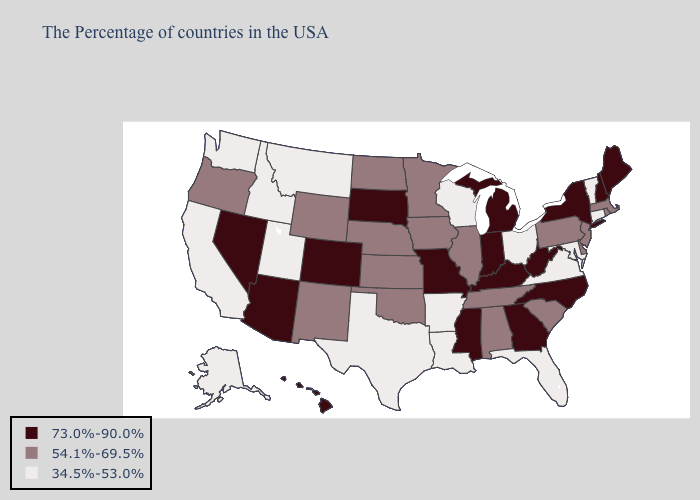Is the legend a continuous bar?
Write a very short answer. No. Name the states that have a value in the range 54.1%-69.5%?
Short answer required. Massachusetts, Rhode Island, New Jersey, Delaware, Pennsylvania, South Carolina, Alabama, Tennessee, Illinois, Minnesota, Iowa, Kansas, Nebraska, Oklahoma, North Dakota, Wyoming, New Mexico, Oregon. What is the value of Arkansas?
Answer briefly. 34.5%-53.0%. What is the lowest value in the West?
Be succinct. 34.5%-53.0%. Name the states that have a value in the range 73.0%-90.0%?
Be succinct. Maine, New Hampshire, New York, North Carolina, West Virginia, Georgia, Michigan, Kentucky, Indiana, Mississippi, Missouri, South Dakota, Colorado, Arizona, Nevada, Hawaii. Does South Dakota have the highest value in the USA?
Write a very short answer. Yes. Name the states that have a value in the range 73.0%-90.0%?
Write a very short answer. Maine, New Hampshire, New York, North Carolina, West Virginia, Georgia, Michigan, Kentucky, Indiana, Mississippi, Missouri, South Dakota, Colorado, Arizona, Nevada, Hawaii. Which states hav the highest value in the Northeast?
Quick response, please. Maine, New Hampshire, New York. Name the states that have a value in the range 73.0%-90.0%?
Write a very short answer. Maine, New Hampshire, New York, North Carolina, West Virginia, Georgia, Michigan, Kentucky, Indiana, Mississippi, Missouri, South Dakota, Colorado, Arizona, Nevada, Hawaii. Name the states that have a value in the range 73.0%-90.0%?
Quick response, please. Maine, New Hampshire, New York, North Carolina, West Virginia, Georgia, Michigan, Kentucky, Indiana, Mississippi, Missouri, South Dakota, Colorado, Arizona, Nevada, Hawaii. What is the highest value in states that border West Virginia?
Concise answer only. 73.0%-90.0%. What is the value of Iowa?
Quick response, please. 54.1%-69.5%. Does Idaho have the lowest value in the West?
Give a very brief answer. Yes. What is the value of Rhode Island?
Give a very brief answer. 54.1%-69.5%. What is the value of Kansas?
Give a very brief answer. 54.1%-69.5%. 